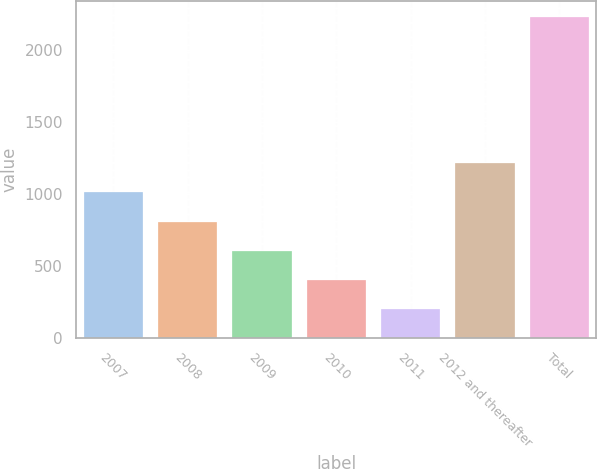Convert chart to OTSL. <chart><loc_0><loc_0><loc_500><loc_500><bar_chart><fcel>2007<fcel>2008<fcel>2009<fcel>2010<fcel>2011<fcel>2012 and thereafter<fcel>Total<nl><fcel>1011.32<fcel>808.54<fcel>605.76<fcel>402.98<fcel>200.2<fcel>1214.1<fcel>2228<nl></chart> 